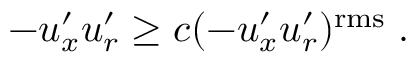Convert formula to latex. <formula><loc_0><loc_0><loc_500><loc_500>- u _ { x } ^ { \prime } u _ { r } ^ { \prime } \geq c ( - u _ { x } ^ { \prime } u _ { r } ^ { \prime } ) ^ { r m s } \, .</formula> 